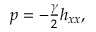<formula> <loc_0><loc_0><loc_500><loc_500>\begin{array} { r } { p = - \frac { \gamma } { 2 } h _ { x x } , } \end{array}</formula> 